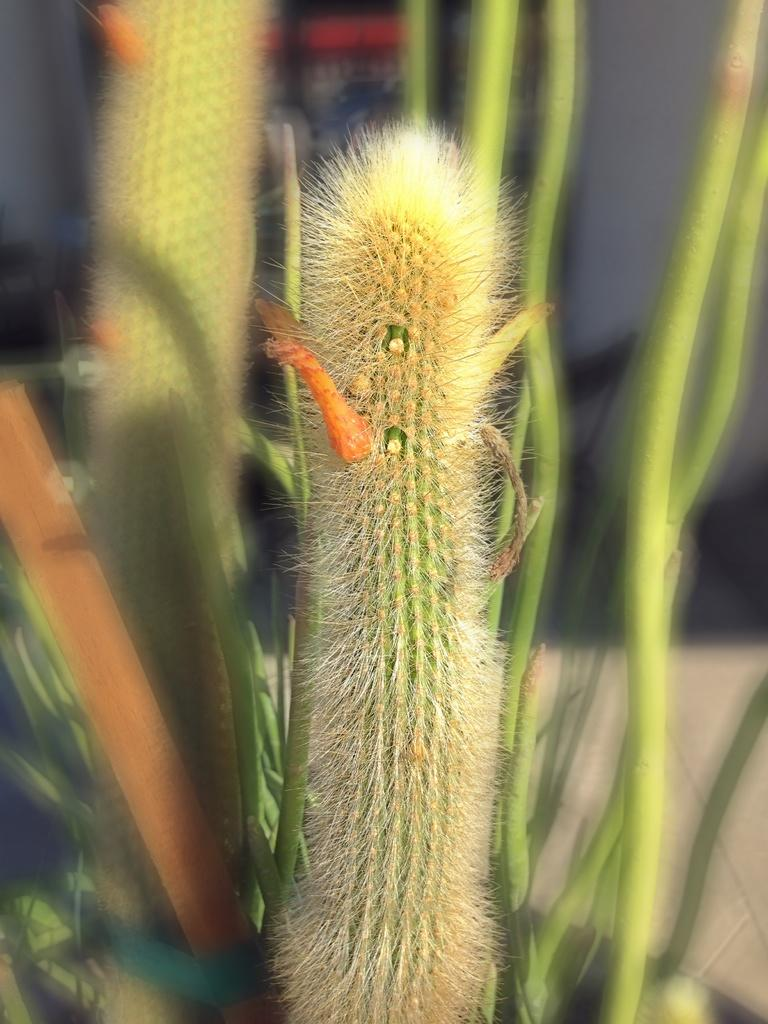What is present in the image? There is a plant in the image. Can you describe the colors of the plant? The plant has green, orange, and cream colors. What else can be seen in the background of the image? There are other plants in the background of the image. What color are the background plants? The background plants are green in color. What type of wine is being served in the vessel in the image? There is no wine or vessel present in the image; it features a plant with green, orange, and cream colors, along with other green plants in the background. 